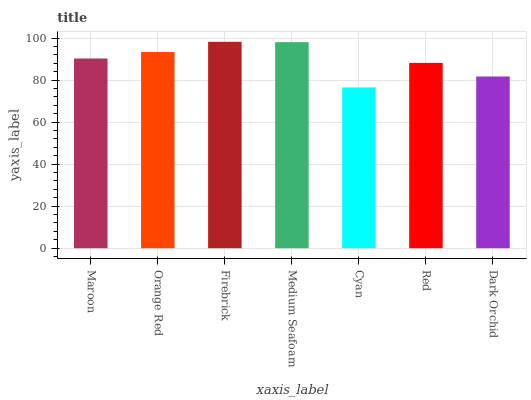Is Cyan the minimum?
Answer yes or no. Yes. Is Firebrick the maximum?
Answer yes or no. Yes. Is Orange Red the minimum?
Answer yes or no. No. Is Orange Red the maximum?
Answer yes or no. No. Is Orange Red greater than Maroon?
Answer yes or no. Yes. Is Maroon less than Orange Red?
Answer yes or no. Yes. Is Maroon greater than Orange Red?
Answer yes or no. No. Is Orange Red less than Maroon?
Answer yes or no. No. Is Maroon the high median?
Answer yes or no. Yes. Is Maroon the low median?
Answer yes or no. Yes. Is Firebrick the high median?
Answer yes or no. No. Is Cyan the low median?
Answer yes or no. No. 